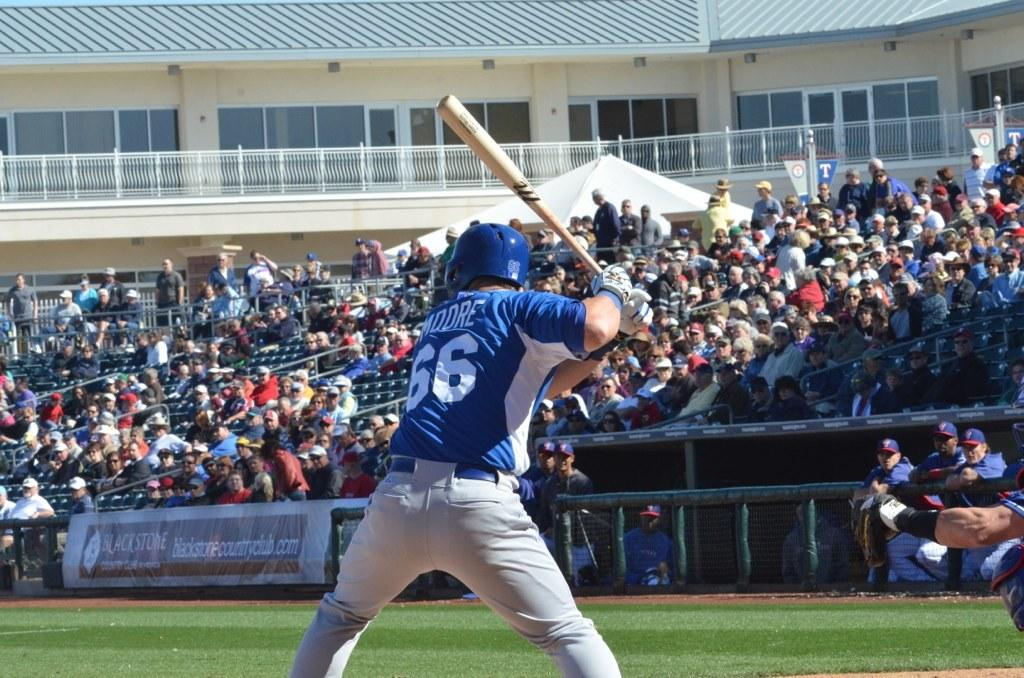<image>
Relay a brief, clear account of the picture shown. a player that is wearing 66 on their baseball jersey 